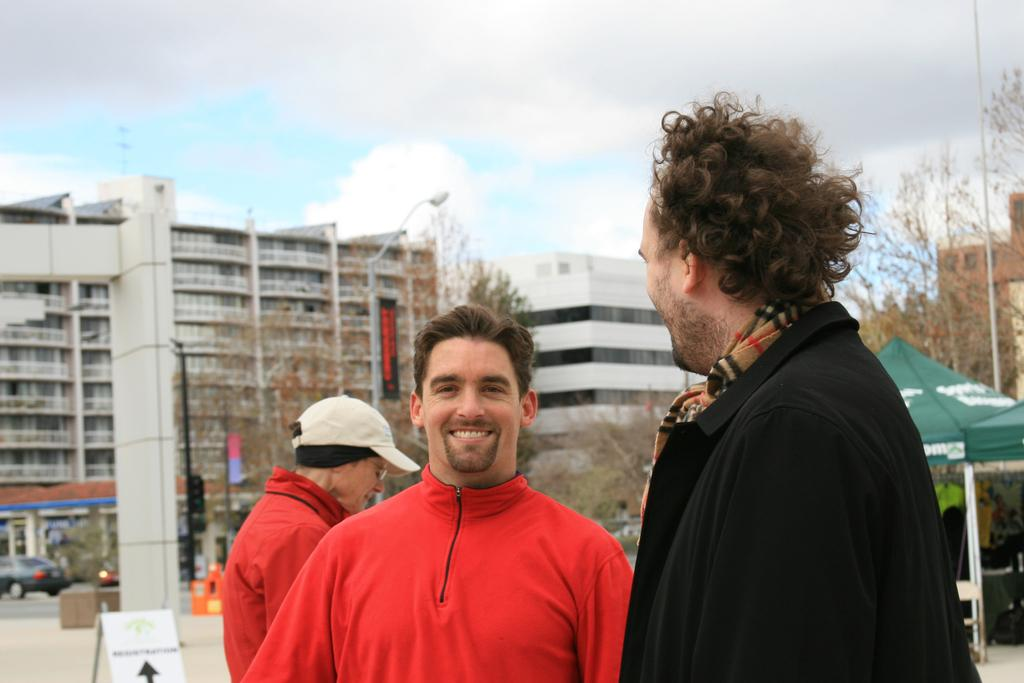How many people are present in the image? There are three persons in the image. What can be seen in the background of the image? There are buildings and trees in the background of the image. What is visible in the sky at the top of the image? There are clouds visible in the sky at the top of the image. What type of cream is being served to the authority figure in the image? There is no authority figure or cream present in the image. 